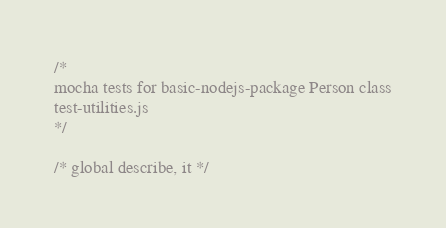Convert code to text. <code><loc_0><loc_0><loc_500><loc_500><_JavaScript_>/*
mocha tests for basic-nodejs-package Person class
test-utilities.js
*/

/* global describe, it */</code> 